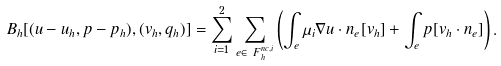Convert formula to latex. <formula><loc_0><loc_0><loc_500><loc_500>& B _ { h } [ ( u - u _ { h } , p - p _ { h } ) , ( v _ { h } , q _ { h } ) ] = \sum ^ { 2 } _ { i = 1 } \sum _ { e \in \ F _ { h } ^ { n c , i } } \left ( \int _ { e } \mu _ { i } \nabla u \cdot n _ { e } [ v _ { h } ] + \int _ { e } p [ v _ { h } \cdot n _ { e } ] \right ) .</formula> 